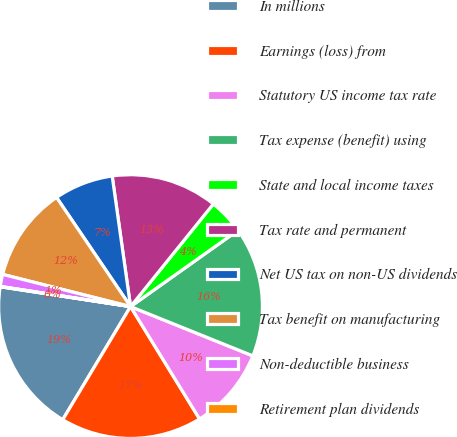Convert chart to OTSL. <chart><loc_0><loc_0><loc_500><loc_500><pie_chart><fcel>In millions<fcel>Earnings (loss) from<fcel>Statutory US income tax rate<fcel>Tax expense (benefit) using<fcel>State and local income taxes<fcel>Tax rate and permanent<fcel>Net US tax on non-US dividends<fcel>Tax benefit on manufacturing<fcel>Non-deductible business<fcel>Retirement plan dividends<nl><fcel>18.81%<fcel>17.36%<fcel>10.14%<fcel>15.92%<fcel>4.37%<fcel>13.03%<fcel>7.26%<fcel>11.59%<fcel>1.48%<fcel>0.04%<nl></chart> 